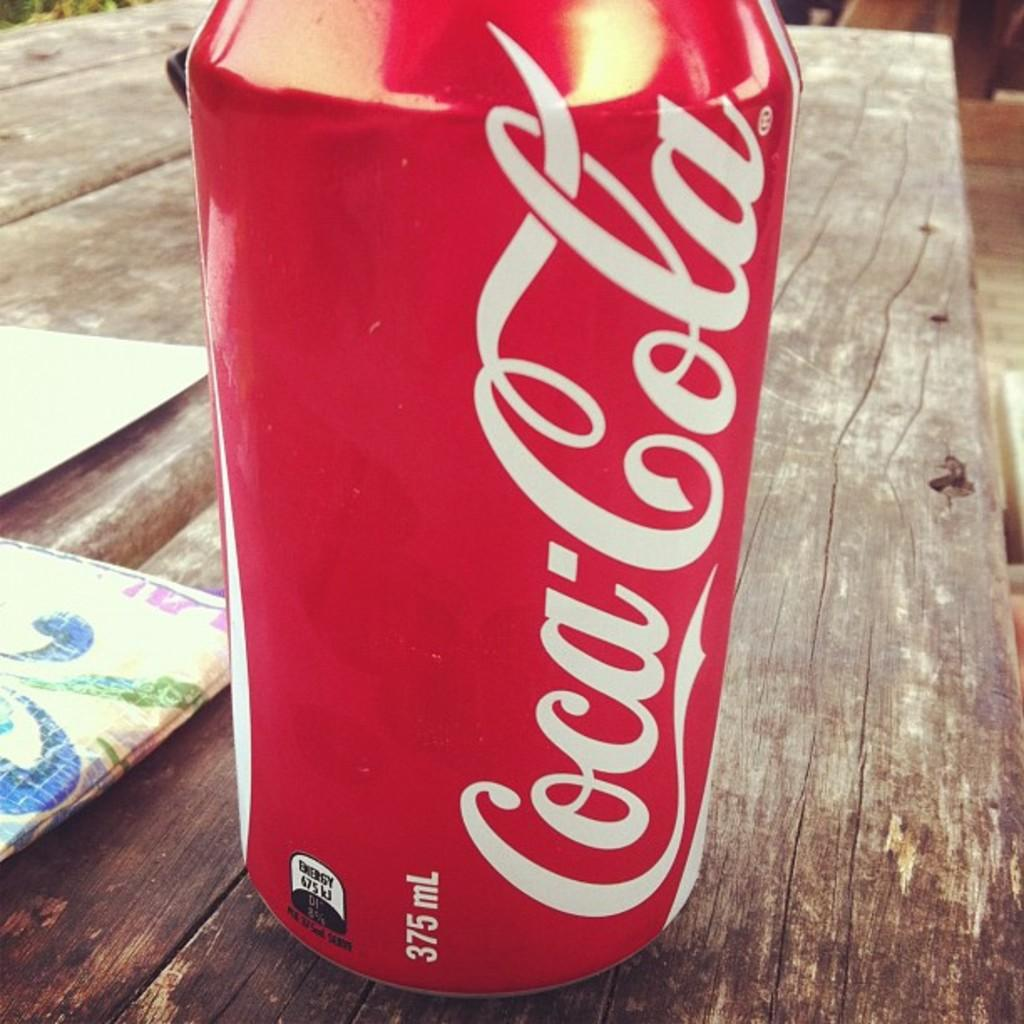Provide a one-sentence caption for the provided image. A can of Coca-Cola, which has a volume of 375 mL, sits atop a wooden table. 